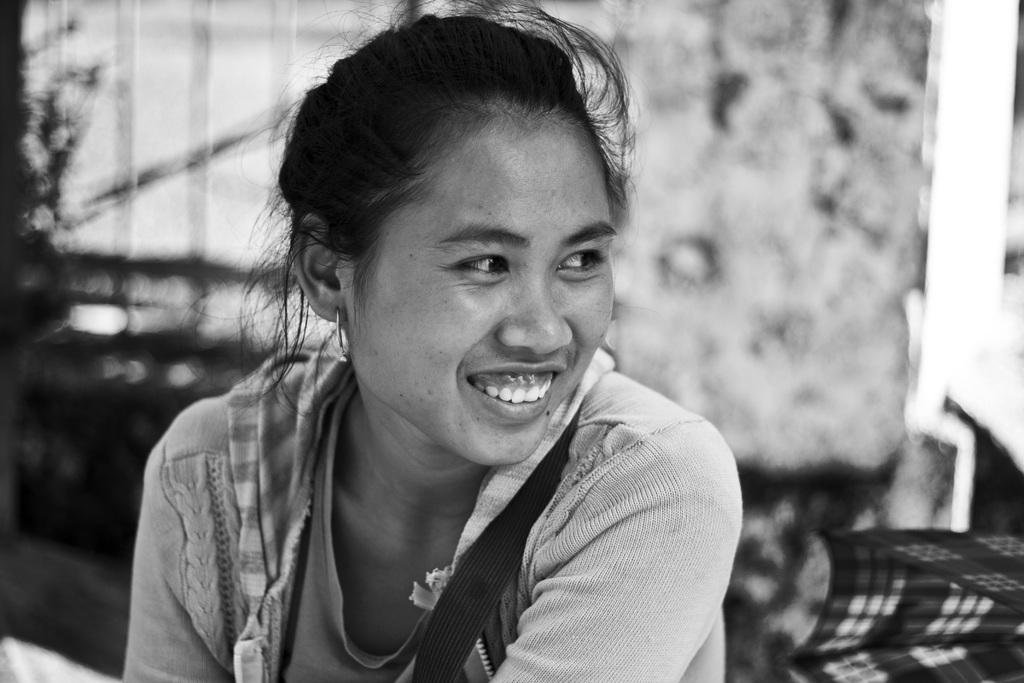What is the color scheme of the picture? The picture is monochrome. Can you describe the main subject in the image? There is a lady in the picture. What is the lady doing in the image? The lady is smiling. What type of camp can be seen in the background of the picture? There is no camp visible in the picture; it is a monochrome image featuring a lady who is smiling. What appliance is the lady using in the picture? There is no appliance present in the picture; it only features a lady who is smiling. 